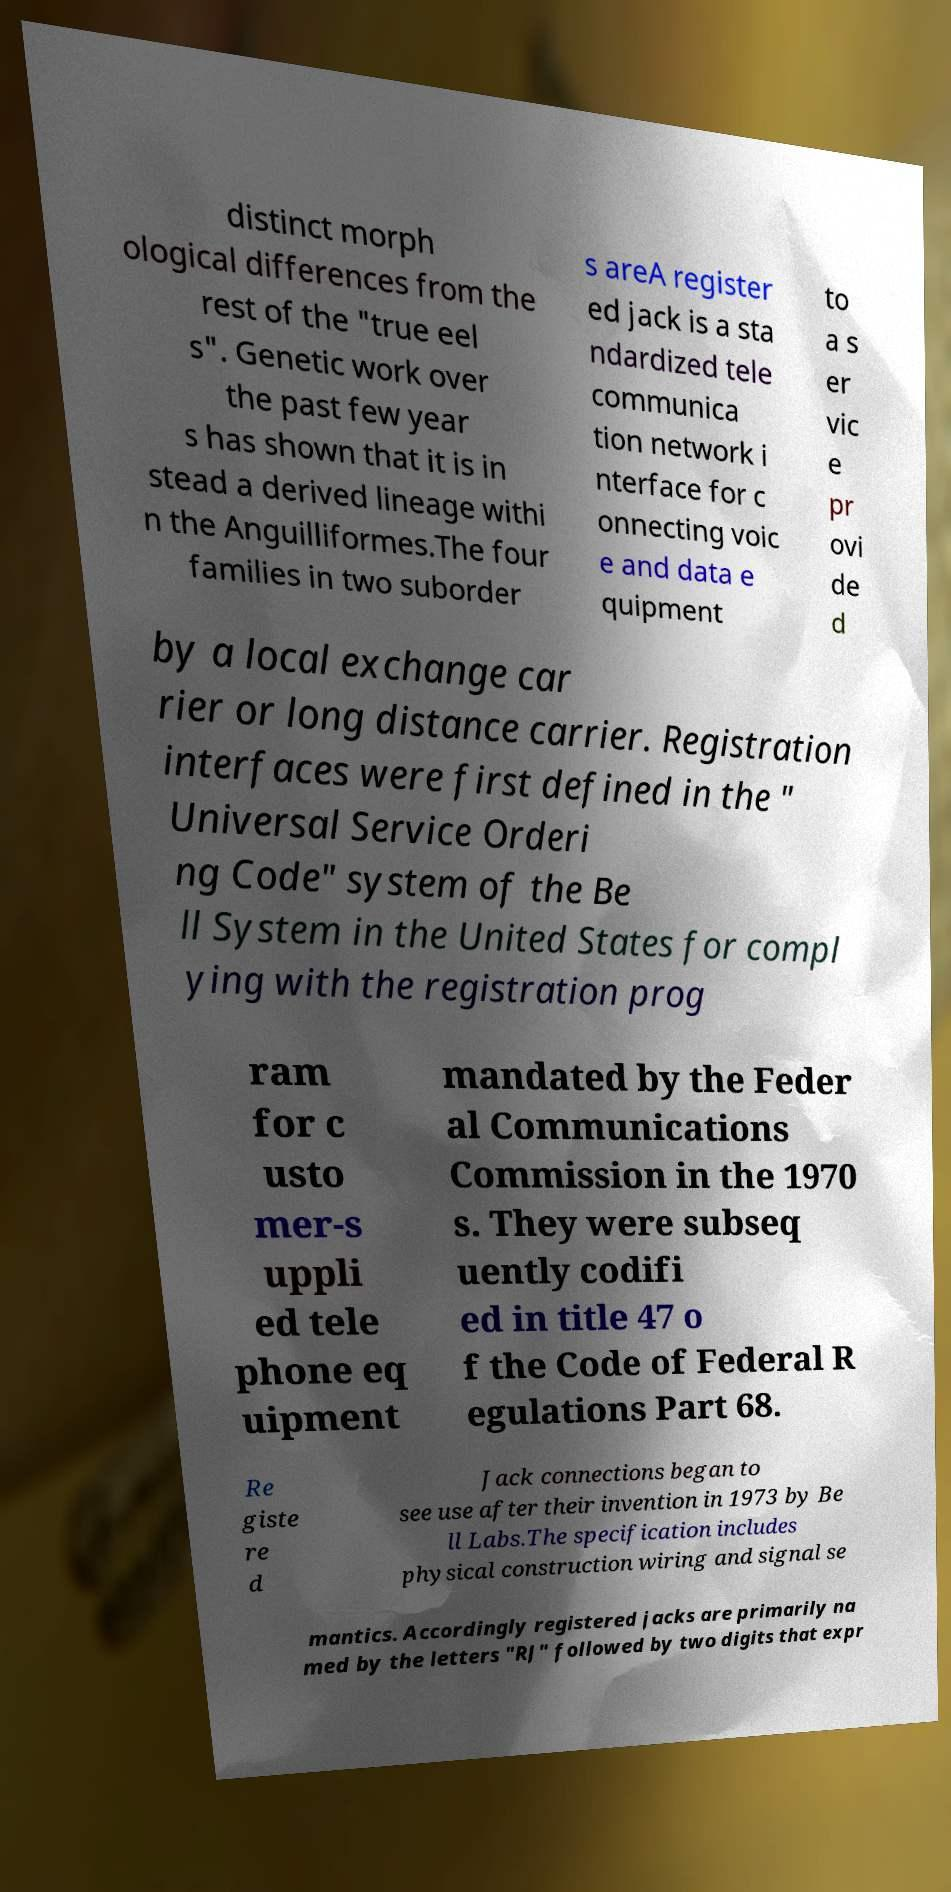Can you accurately transcribe the text from the provided image for me? distinct morph ological differences from the rest of the "true eel s". Genetic work over the past few year s has shown that it is in stead a derived lineage withi n the Anguilliformes.The four families in two suborder s areA register ed jack is a sta ndardized tele communica tion network i nterface for c onnecting voic e and data e quipment to a s er vic e pr ovi de d by a local exchange car rier or long distance carrier. Registration interfaces were first defined in the " Universal Service Orderi ng Code" system of the Be ll System in the United States for compl ying with the registration prog ram for c usto mer-s uppli ed tele phone eq uipment mandated by the Feder al Communications Commission in the 1970 s. They were subseq uently codifi ed in title 47 o f the Code of Federal R egulations Part 68. Re giste re d Jack connections began to see use after their invention in 1973 by Be ll Labs.The specification includes physical construction wiring and signal se mantics. Accordingly registered jacks are primarily na med by the letters "RJ" followed by two digits that expr 